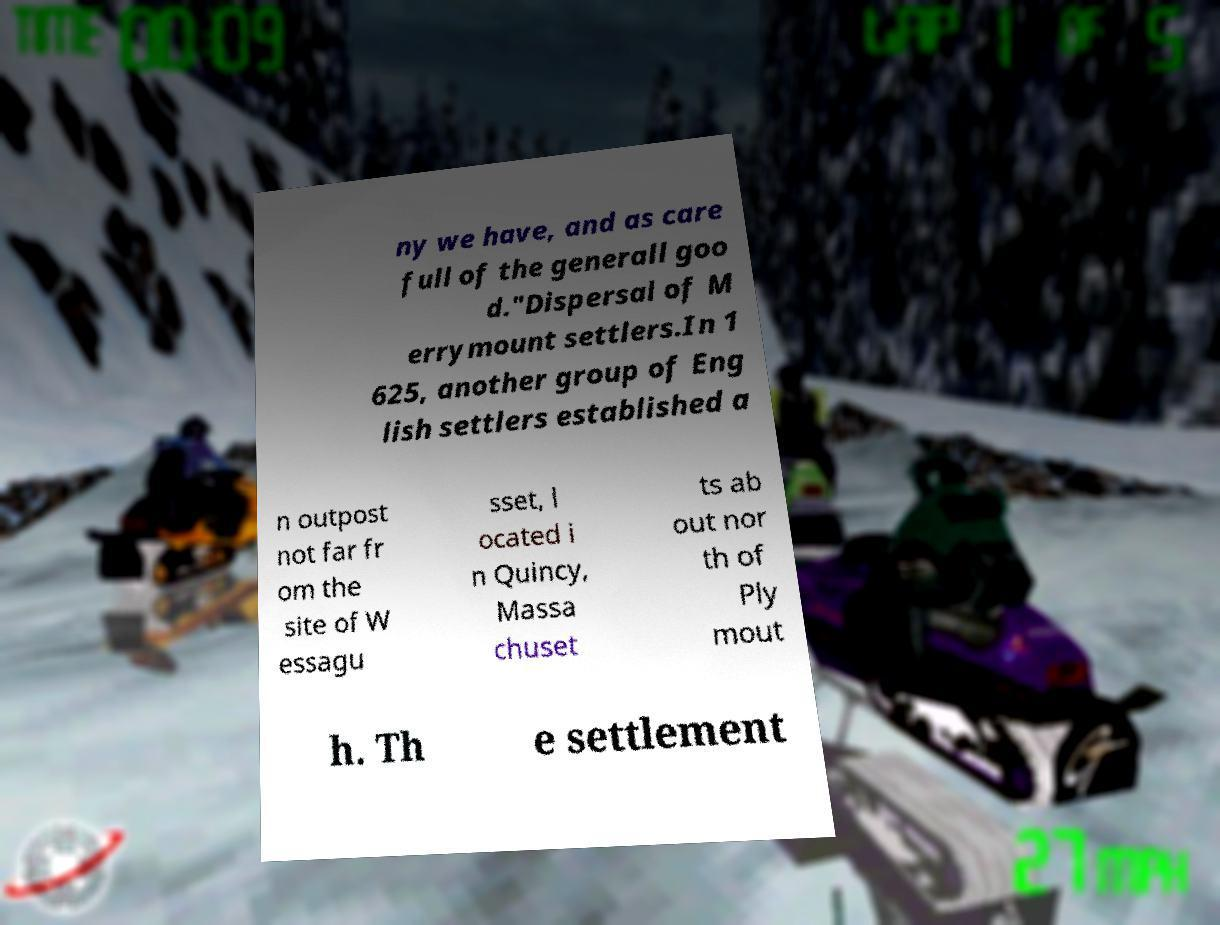Can you accurately transcribe the text from the provided image for me? ny we have, and as care full of the generall goo d."Dispersal of M errymount settlers.In 1 625, another group of Eng lish settlers established a n outpost not far fr om the site of W essagu sset, l ocated i n Quincy, Massa chuset ts ab out nor th of Ply mout h. Th e settlement 